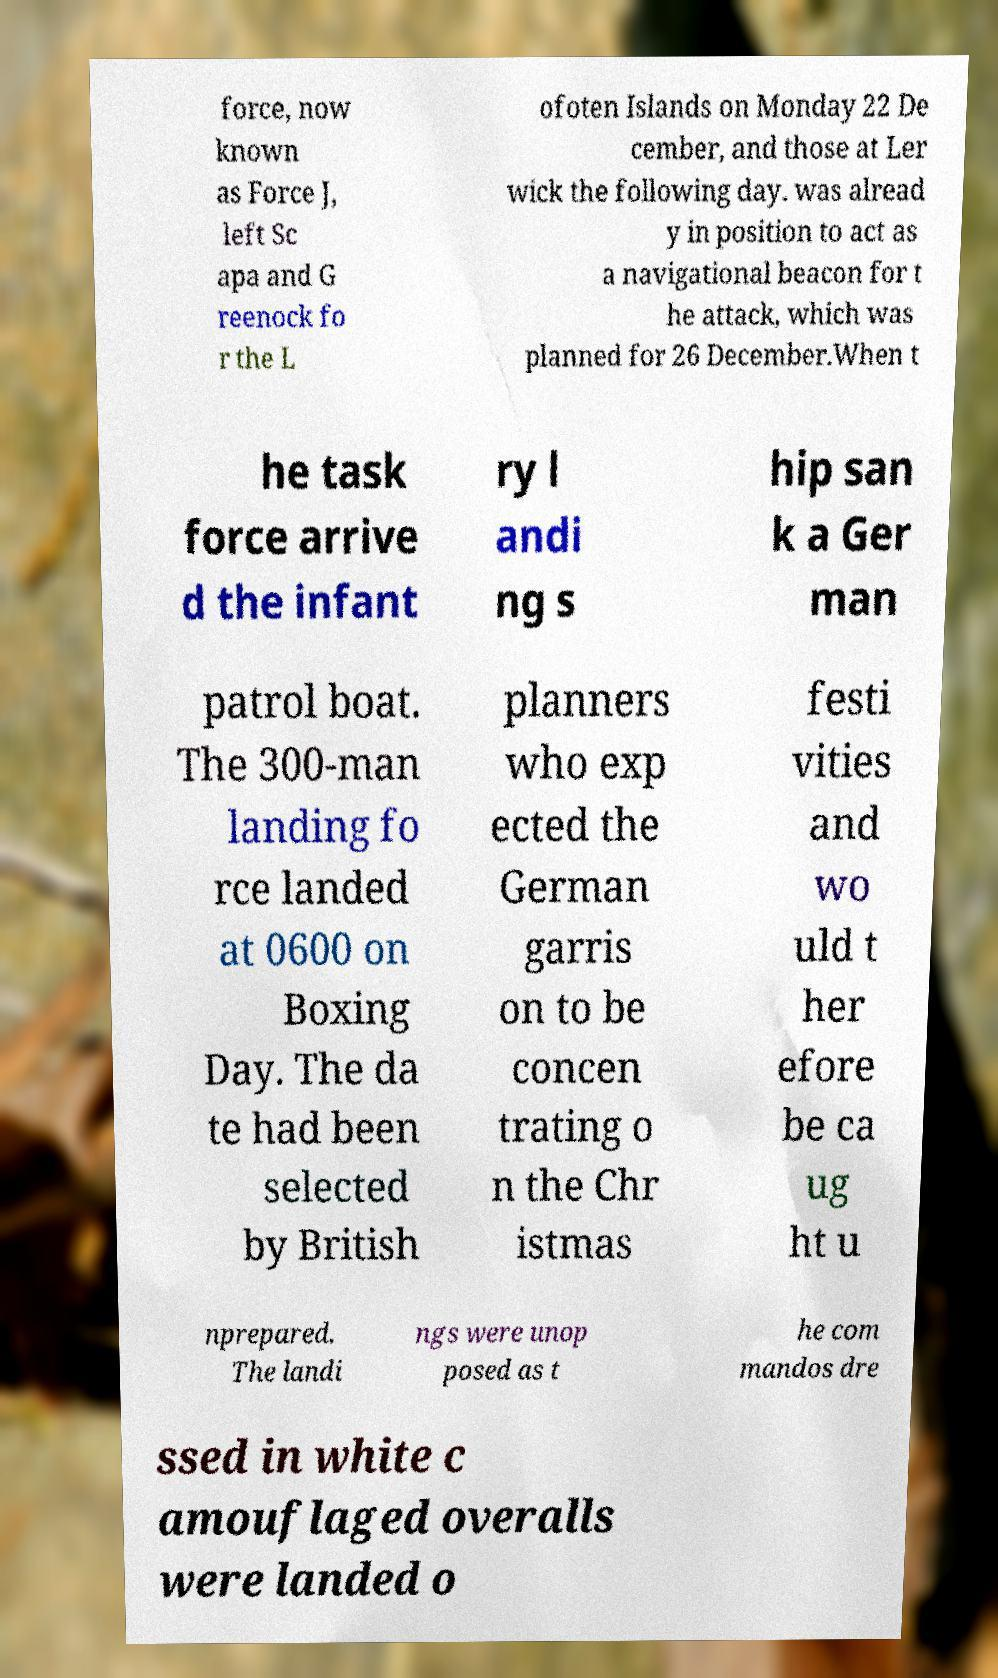Could you assist in decoding the text presented in this image and type it out clearly? force, now known as Force J, left Sc apa and G reenock fo r the L ofoten Islands on Monday 22 De cember, and those at Ler wick the following day. was alread y in position to act as a navigational beacon for t he attack, which was planned for 26 December.When t he task force arrive d the infant ry l andi ng s hip san k a Ger man patrol boat. The 300-man landing fo rce landed at 0600 on Boxing Day. The da te had been selected by British planners who exp ected the German garris on to be concen trating o n the Chr istmas festi vities and wo uld t her efore be ca ug ht u nprepared. The landi ngs were unop posed as t he com mandos dre ssed in white c amouflaged overalls were landed o 